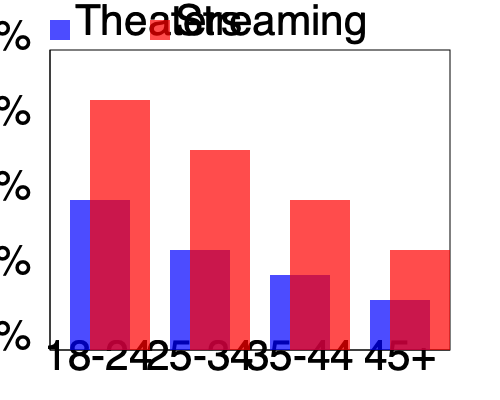Based on the histogram showing age group distribution for theater and streaming platform audiences, which demographic shift poses the greatest challenge for traditional movie theaters, and what strategy might a film producer employ to address this issue? To answer this question, let's analyze the histogram step-by-step:

1. Age group comparison:
   - 18-24: Streaming significantly outperforms theaters
   - 25-34: Streaming maintains a strong lead over theaters
   - 35-44: Streaming still leads, but the gap narrows
   - 45+: Theaters and streaming are closest, with streaming slightly ahead

2. Key observations:
   - Younger audiences (18-34) heavily prefer streaming platforms
   - The preference for streaming decreases with age
   - Theaters perform best with the 45+ age group

3. Greatest challenge:
   The most significant challenge for theaters is the low attendance from the 18-24 and 25-34 age groups. These younger audiences are crucial for long-term sustainability and are currently heavily skewed towards streaming platforms.

4. Strategy for a film producer:
   To address this issue, a film producer could focus on creating immersive, event-style movie experiences that cannot be replicated at home. This strategy might include:

   a) Developing films with stunning visual effects and sound design that benefit from the theater experience
   b) Creating more interactive movie events, such as sing-alongs or costume contests
   c) Partnering with theaters to offer exclusive content or behind-the-scenes features
   d) Producing films that appeal to younger audiences but are designed for group viewing experiences

5. Rationale:
   By emphasizing the unique aspects of the theater experience, producers can create a compelling reason for younger audiences to choose theaters over streaming. This approach leverages the social and experiential aspects of movie-going that streaming platforms cannot easily replicate.
Answer: Create immersive, event-style movie experiences targeting younger audiences (18-34) that cannot be replicated at home. 